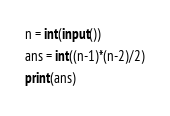<code> <loc_0><loc_0><loc_500><loc_500><_Python_>n = int(input())
ans = int((n-1)*(n-2)/2)
print(ans)</code> 